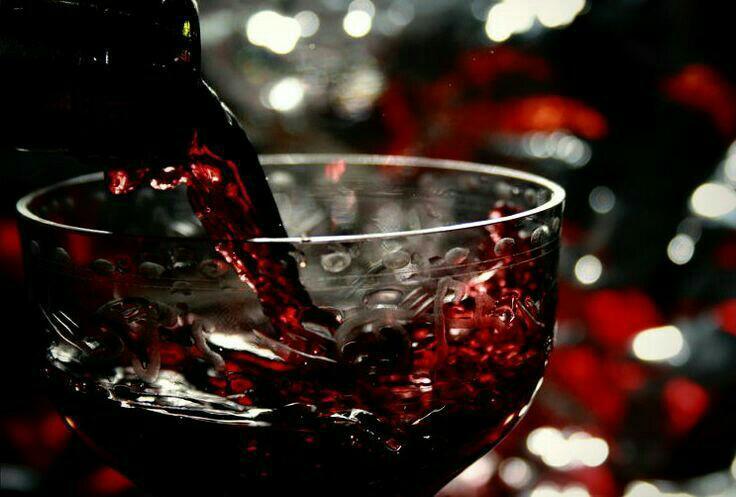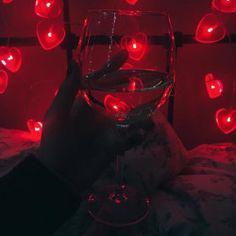The first image is the image on the left, the second image is the image on the right. Considering the images on both sides, is "Wine is pouring from a bottle into a glass in the right image." valid? Answer yes or no. No. 